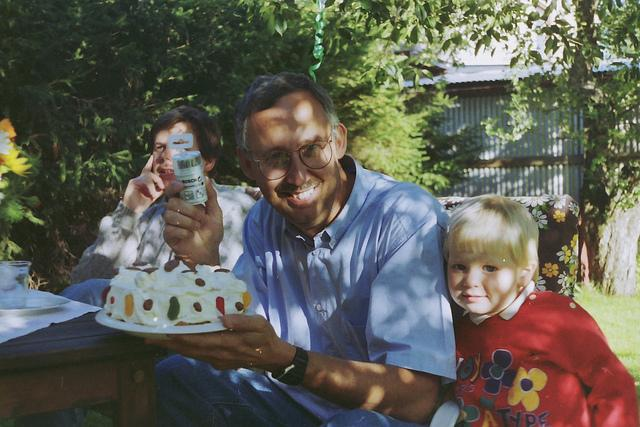What this man doing? Please explain your reasoning. decorating cake. The man is holding a cake and adding decorations to it. 